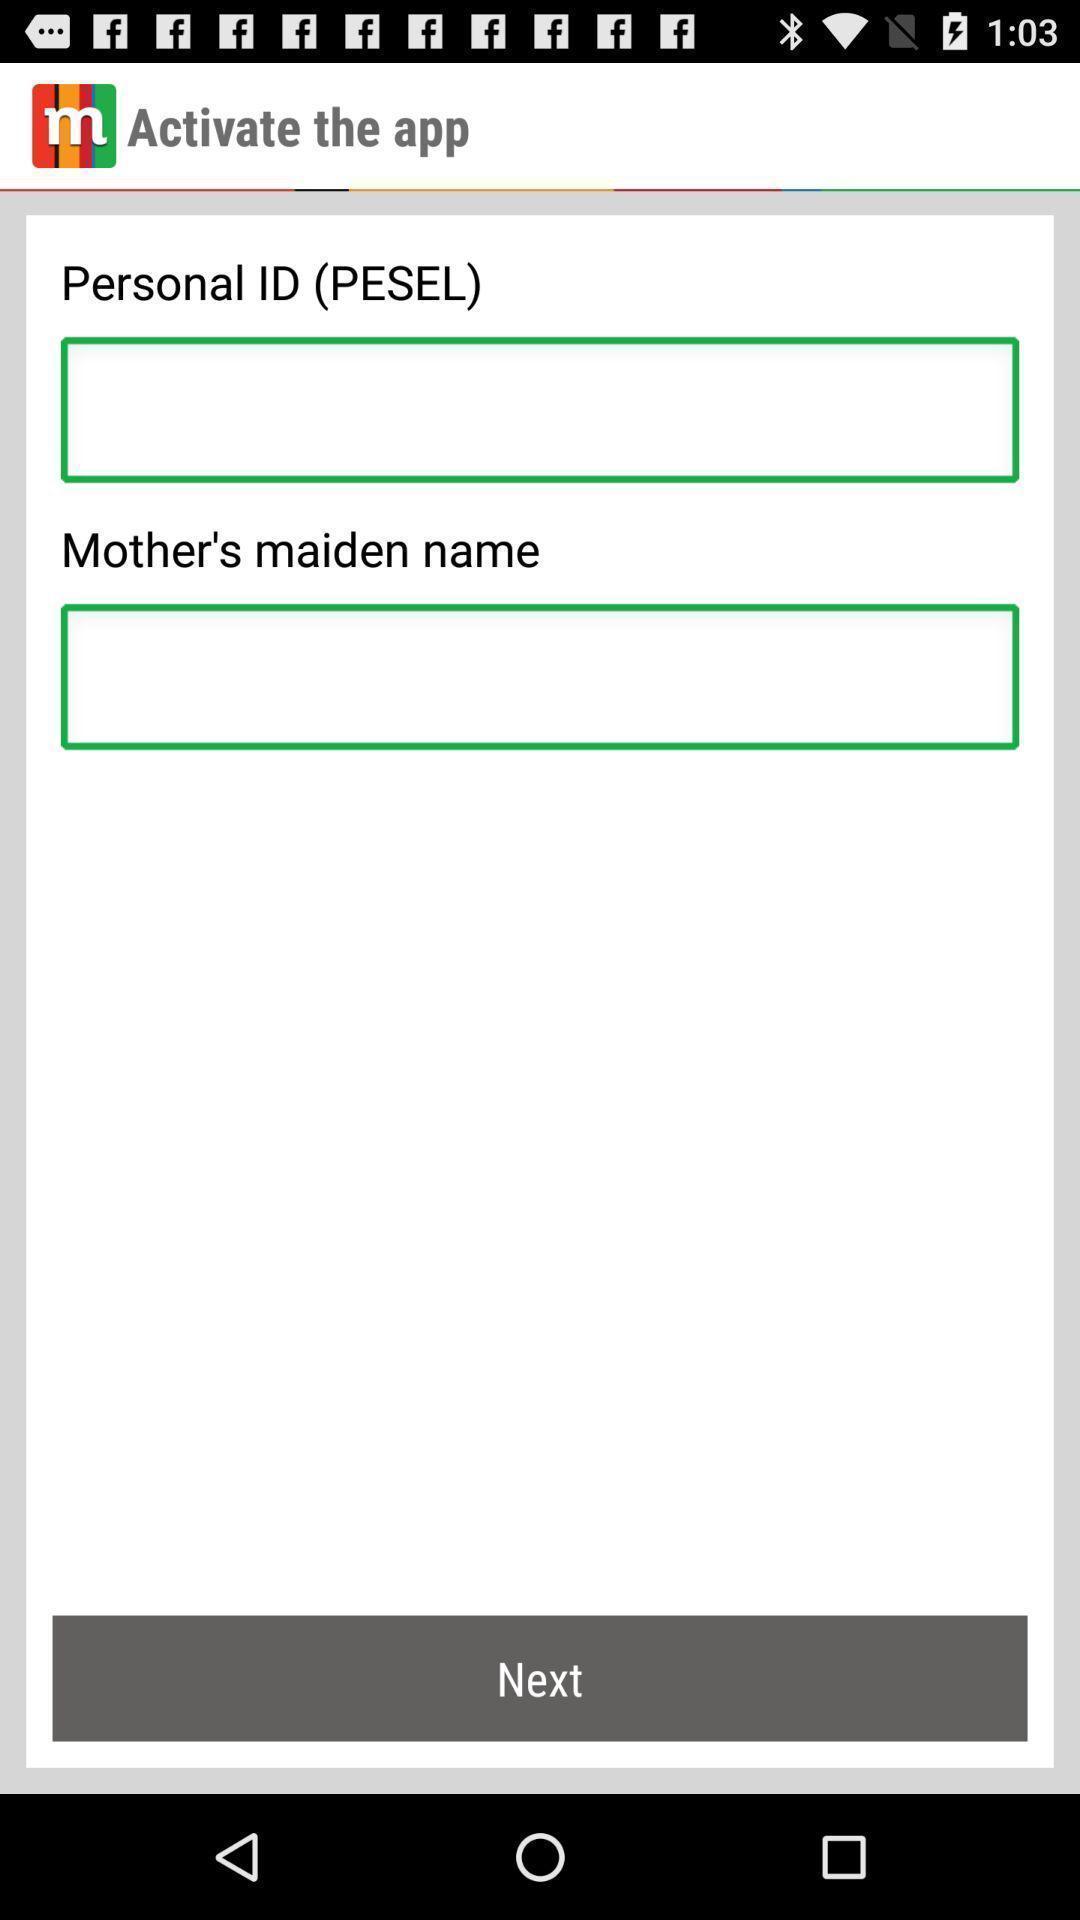Give me a summary of this screen capture. Page displaying to enter the details. 